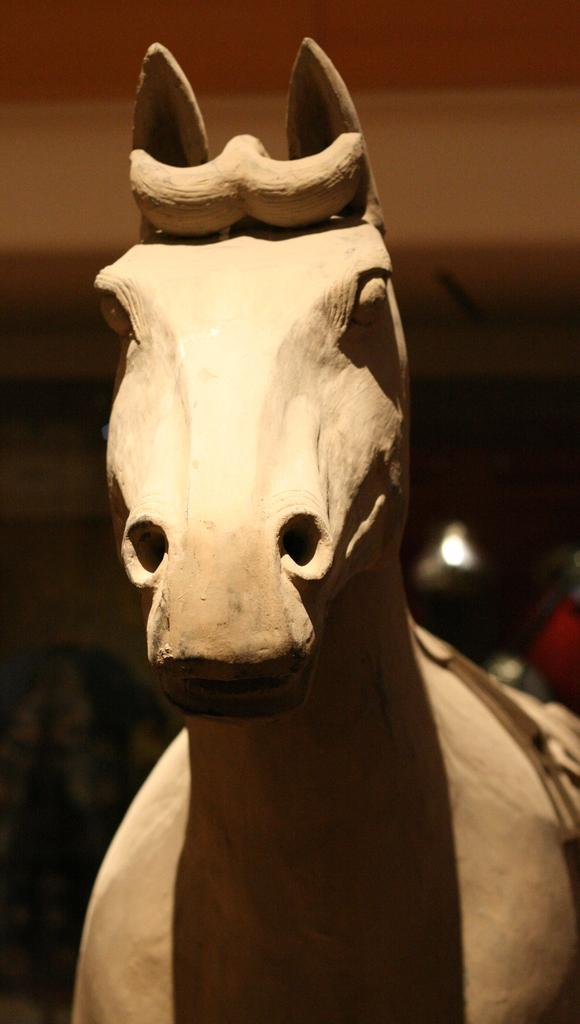What is the main subject of the image? There is a statue of a horse in the image. Can you describe the statue in more detail? Unfortunately, the back of the image is dark and blurry, so it's difficult to provide more details about the statue. Where is the mother holding the toothbrush in the image? There is no mother or toothbrush present in the image; it only features a statue of a horse. 